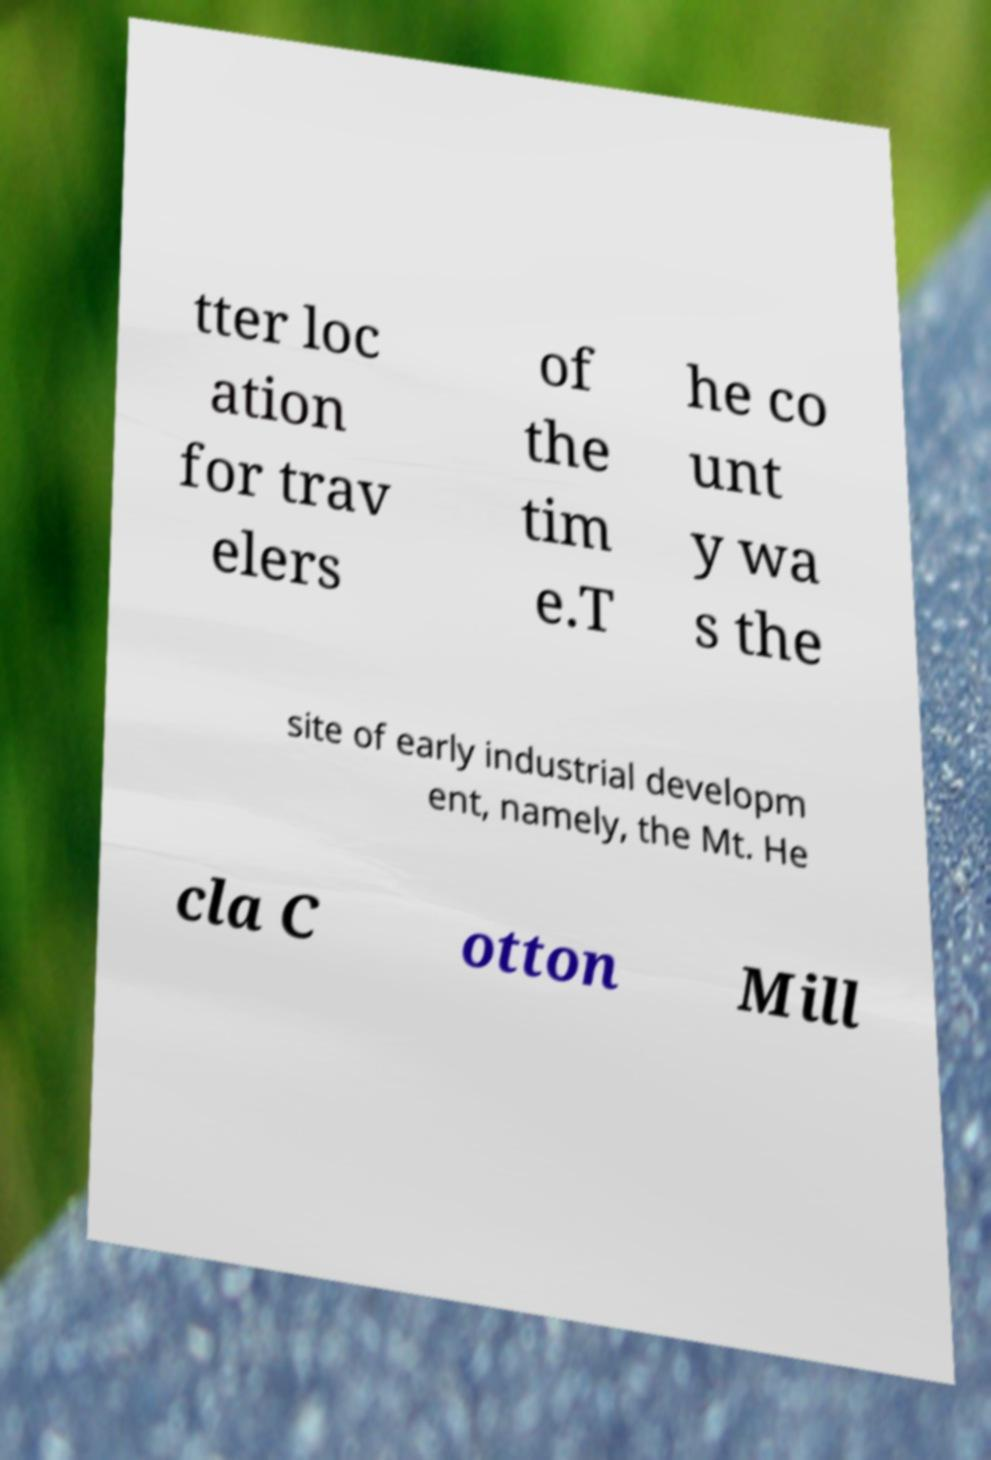Can you read and provide the text displayed in the image?This photo seems to have some interesting text. Can you extract and type it out for me? tter loc ation for trav elers of the tim e.T he co unt y wa s the site of early industrial developm ent, namely, the Mt. He cla C otton Mill 